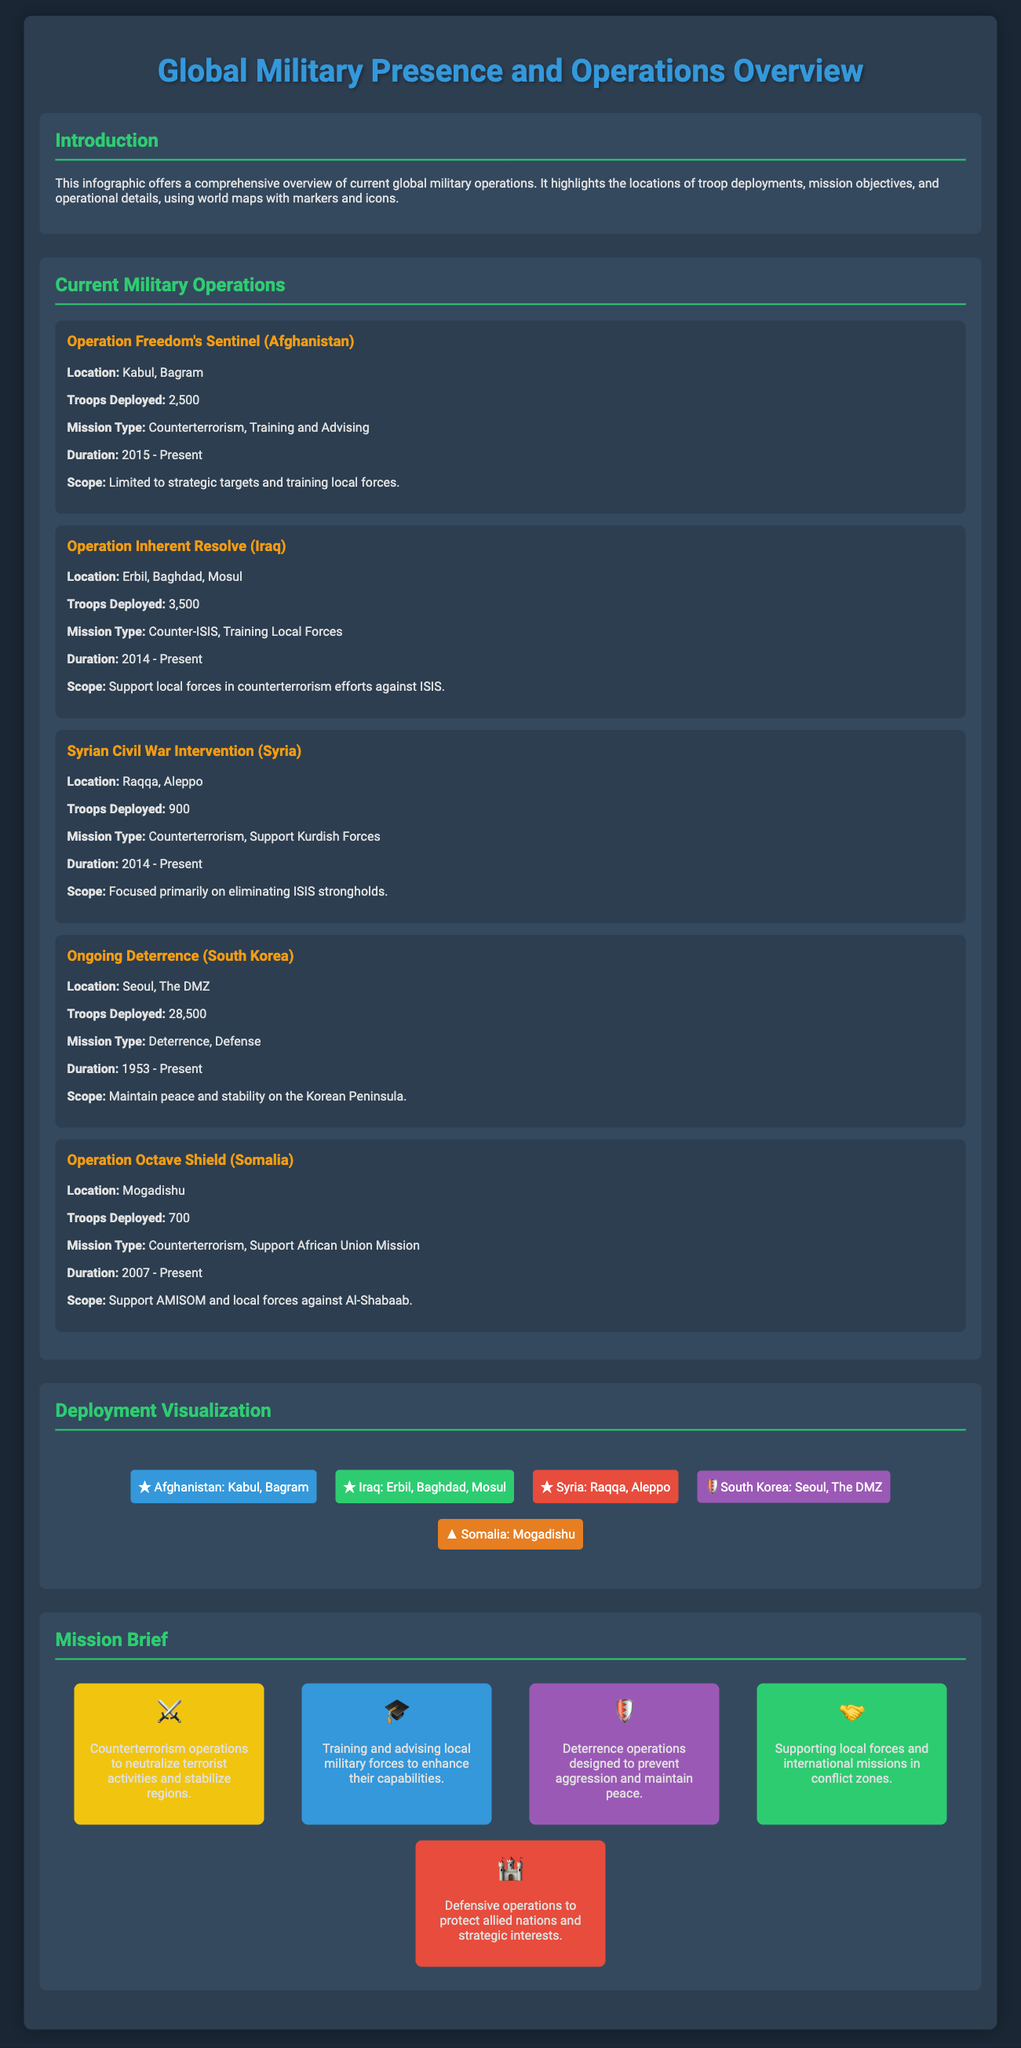What is the mission type of Operation Freedom's Sentinel? The mission type of Operation Freedom's Sentinel is listed as counterterrorism and training and advising.
Answer: Counterterrorism, Training and Advising How many troops are deployed in Iraq for Operation Inherent Resolve? The number of troops deployed in Iraq for Operation Inherent Resolve is specified in the document as 3,500.
Answer: 3,500 What is the duration of the Ongoing Deterrence operation in South Korea? The duration of the Ongoing Deterrence operation is mentioned as from 1953 to present in the document.
Answer: 1953 - Present Which country has the highest number of deployed troops listed in the document? The country with the highest number of deployed troops is South Korea, with 28,500 troops noted in the document.
Answer: South Korea What are the operational locations for the Syrian Civil War Intervention? The operational locations for the Syrian Civil War Intervention include Raqqa and Aleppo, as stated in the infographic.
Answer: Raqqa, Aleppo What type of missions are indicated by the icon representing training local forces? The icon representing training local forces corresponds to the mission type that involves enhancing capabilities through support, as described in the document.
Answer: Training and Advising How many ongoing military operations are listed in the document? The document lists a total of five ongoing military operations, which can be counted from the sections provided.
Answer: 5 What is the primary scope of Operation Octave Shield? The primary scope of Operation Octave Shield is indicated as supporting AMISOM and local forces against Al-Shabaab.
Answer: Support AMISOM and local forces against Al-Shabaab What visual element is used to represent Iraq in the deployment visualization? The visual element used to represent Iraq in the deployment visualization is a map marker that is colored green in the document.
Answer: Green map marker 